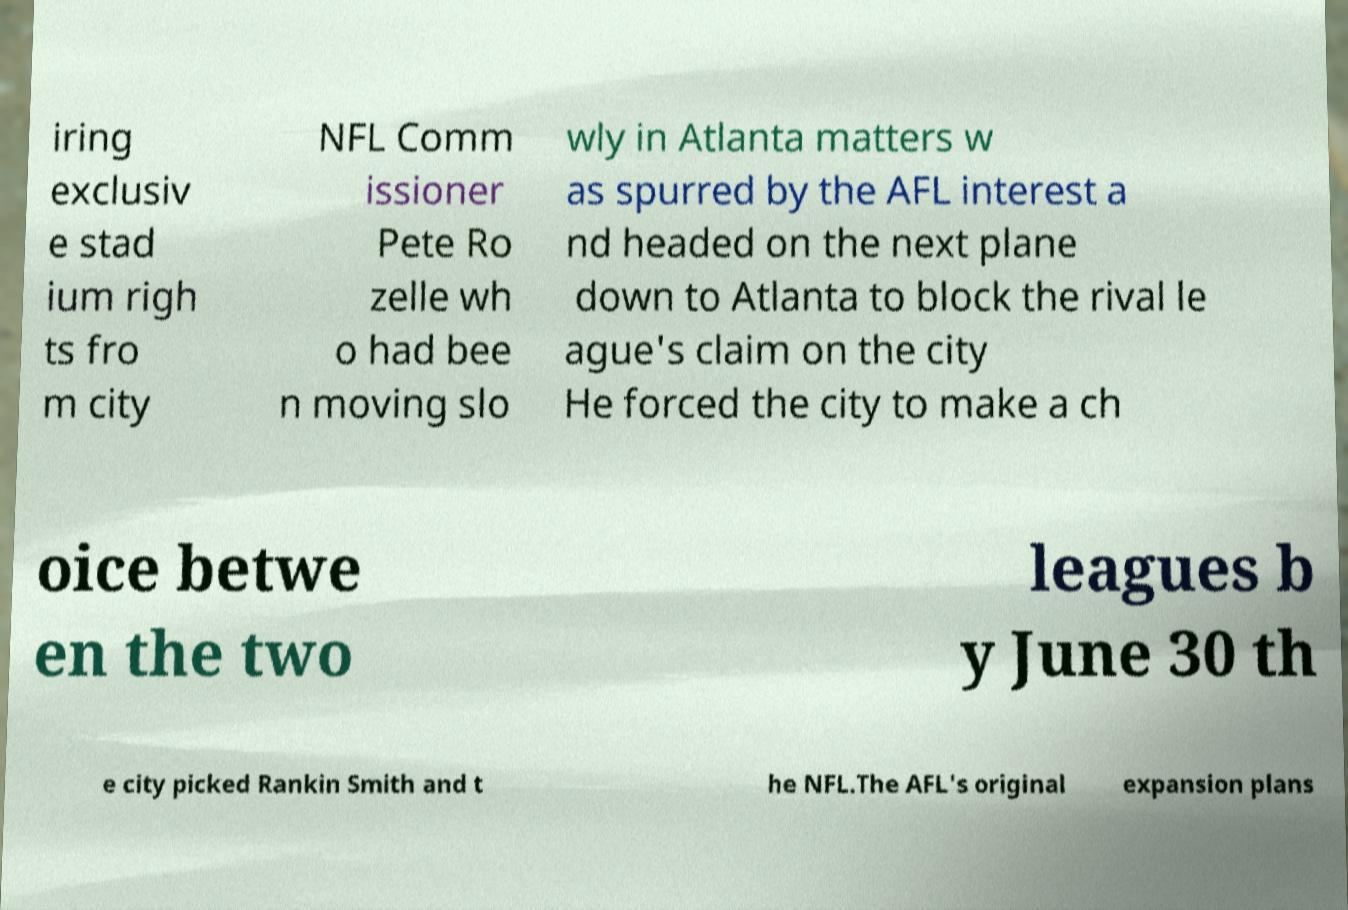Can you read and provide the text displayed in the image?This photo seems to have some interesting text. Can you extract and type it out for me? iring exclusiv e stad ium righ ts fro m city NFL Comm issioner Pete Ro zelle wh o had bee n moving slo wly in Atlanta matters w as spurred by the AFL interest a nd headed on the next plane down to Atlanta to block the rival le ague's claim on the city He forced the city to make a ch oice betwe en the two leagues b y June 30 th e city picked Rankin Smith and t he NFL.The AFL's original expansion plans 